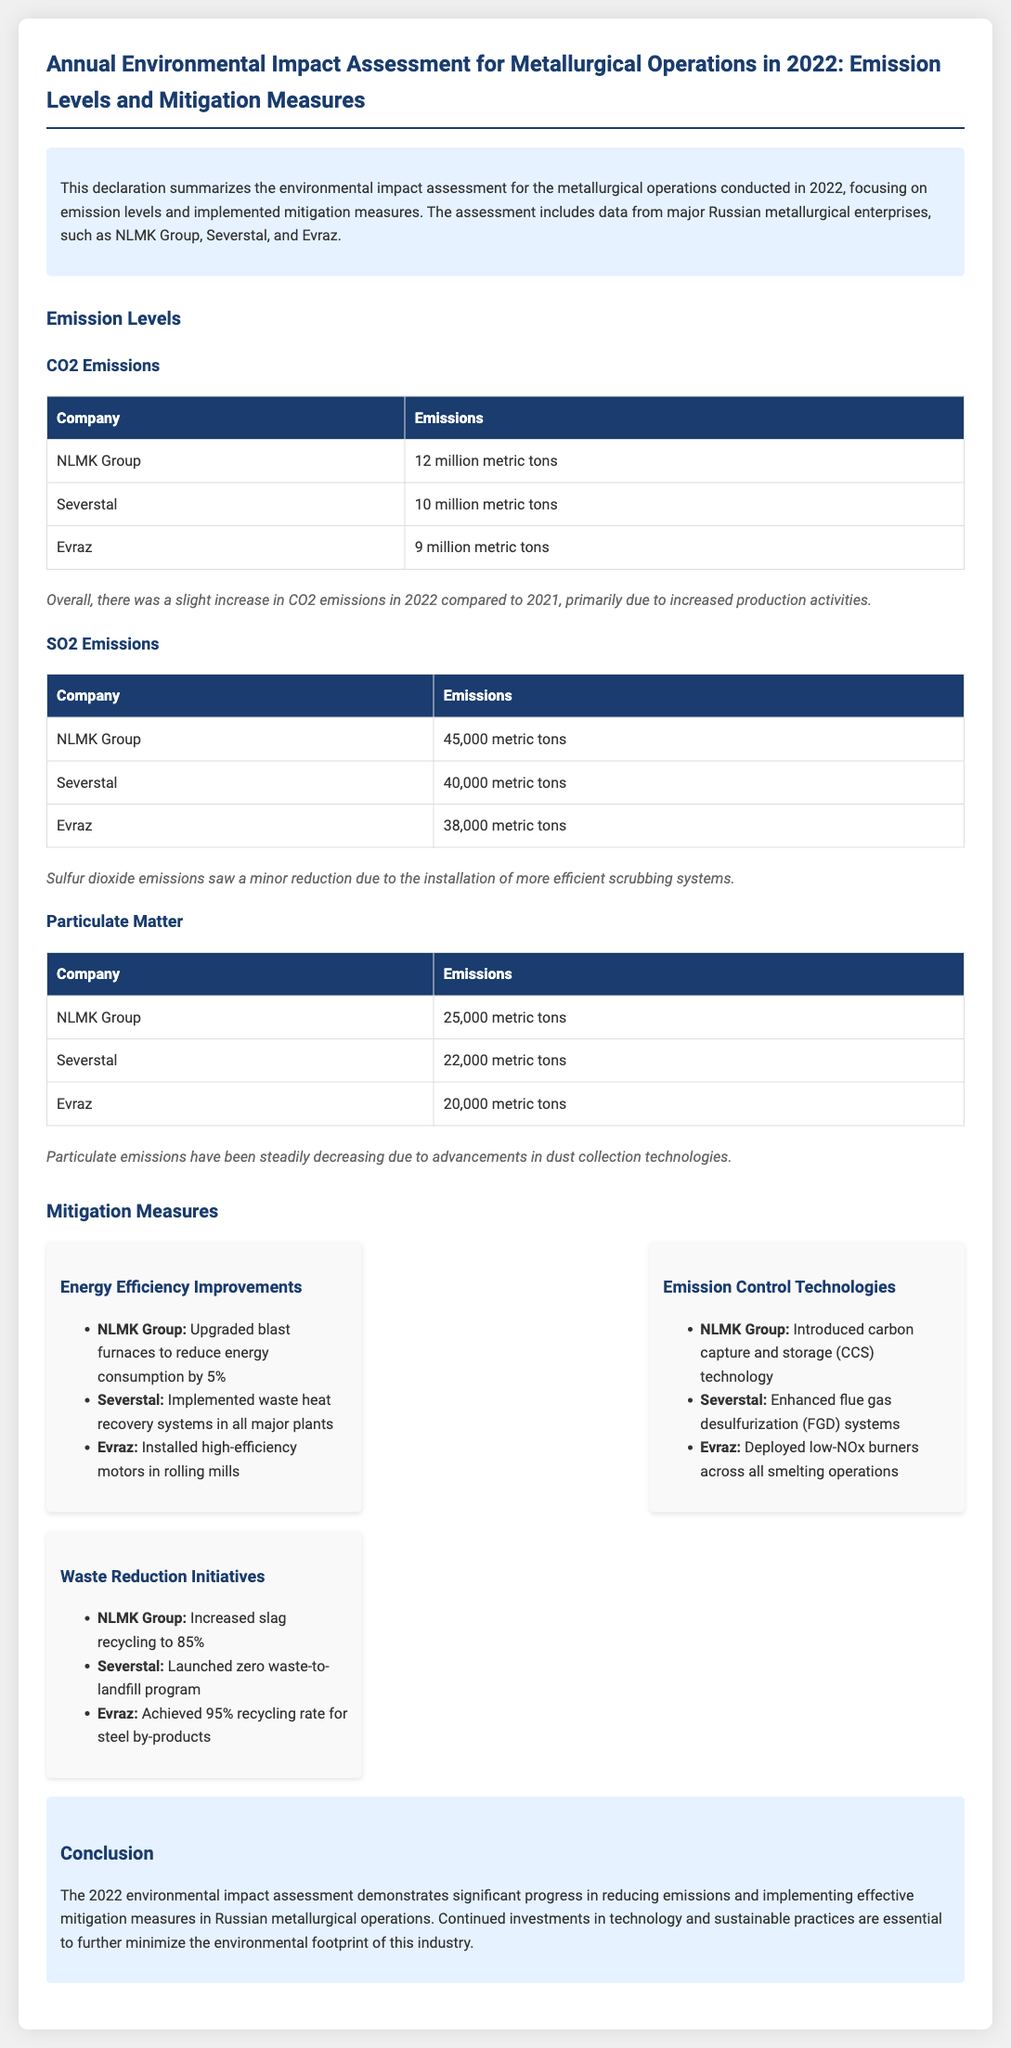What is the total CO2 emissions for NLMK Group? The total CO2 emissions for NLMK Group in 2022 is stated directly in the document.
Answer: 12 million metric tons How much did Severstal reduce SO2 emissions? The document states that sulfur dioxide emissions saw a minor reduction, which indicates a change compared to previous levels without giving a specific figure.
Answer: Minor reduction What technology did NLMK Group introduce for emissions control? The document lists specific emission control technologies implemented by various companies, focusing on NLMK Group.
Answer: Carbon capture and storage (CCS) technology What was the recycling rate of steel by-products for Evraz? The document explicitly mentions the achieved recycling rate for Evraz's steel by-products in 2022.
Answer: 95% Which company upgraded blast furnaces to reduce energy consumption? The document names specific companies associated with different mitigation measures regarding energy efficiency improvements.
Answer: NLMK Group What type of emissions saw a decrease due to dust collection technologies? The document describes advancements that lead to a decrease in specific emissions linked to dust collection technologies.
Answer: Particulate Matter How many metric tons of SO2 did Evraz emit? The document provides specific SO2 emission figures for each company, including Evraz.
Answer: 38,000 metric tons What emissions experienced a slight increase in 2022? The document outlines the overall trends in emissions for the year 2022, identifying any increases in particular pollutants.
Answer: CO2 emissions 